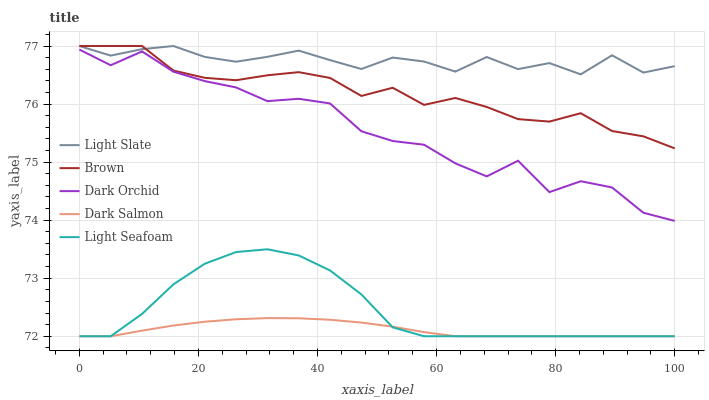Does Dark Salmon have the minimum area under the curve?
Answer yes or no. Yes. Does Light Slate have the maximum area under the curve?
Answer yes or no. Yes. Does Brown have the minimum area under the curve?
Answer yes or no. No. Does Brown have the maximum area under the curve?
Answer yes or no. No. Is Dark Salmon the smoothest?
Answer yes or no. Yes. Is Dark Orchid the roughest?
Answer yes or no. Yes. Is Brown the smoothest?
Answer yes or no. No. Is Brown the roughest?
Answer yes or no. No. Does Light Seafoam have the lowest value?
Answer yes or no. Yes. Does Brown have the lowest value?
Answer yes or no. No. Does Brown have the highest value?
Answer yes or no. Yes. Does Light Seafoam have the highest value?
Answer yes or no. No. Is Light Seafoam less than Dark Orchid?
Answer yes or no. Yes. Is Light Slate greater than Dark Salmon?
Answer yes or no. Yes. Does Light Slate intersect Brown?
Answer yes or no. Yes. Is Light Slate less than Brown?
Answer yes or no. No. Is Light Slate greater than Brown?
Answer yes or no. No. Does Light Seafoam intersect Dark Orchid?
Answer yes or no. No. 